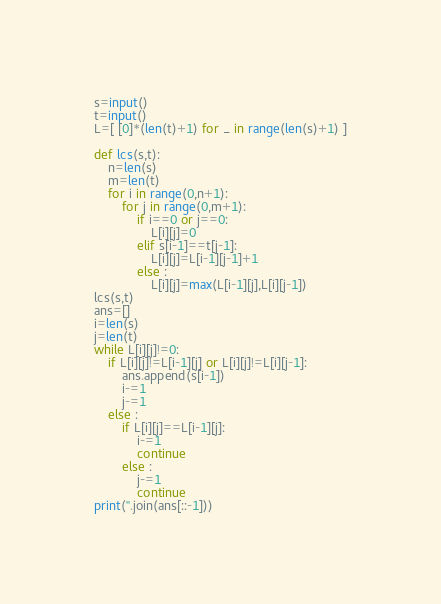<code> <loc_0><loc_0><loc_500><loc_500><_Python_>s=input()
t=input()
L=[ [0]*(len(t)+1) for _ in range(len(s)+1) ]

def lcs(s,t):
    n=len(s)
    m=len(t)
    for i in range(0,n+1):
        for j in range(0,m+1):
            if i==0 or j==0:
                L[i][j]=0
            elif s[i-1]==t[j-1]:
                L[i][j]=L[i-1][j-1]+1
            else :
                L[i][j]=max(L[i-1][j],L[i][j-1])
lcs(s,t)
ans=[]
i=len(s)
j=len(t)
while L[i][j]!=0:
    if L[i][j]!=L[i-1][j] or L[i][j]!=L[i][j-1]:
        ans.append(s[i-1])
        i-=1
        j-=1
    else :
        if L[i][j]==L[i-1][j]:
            i-=1
            continue
        else :
            j-=1
            continue
print(''.join(ans[::-1]))</code> 